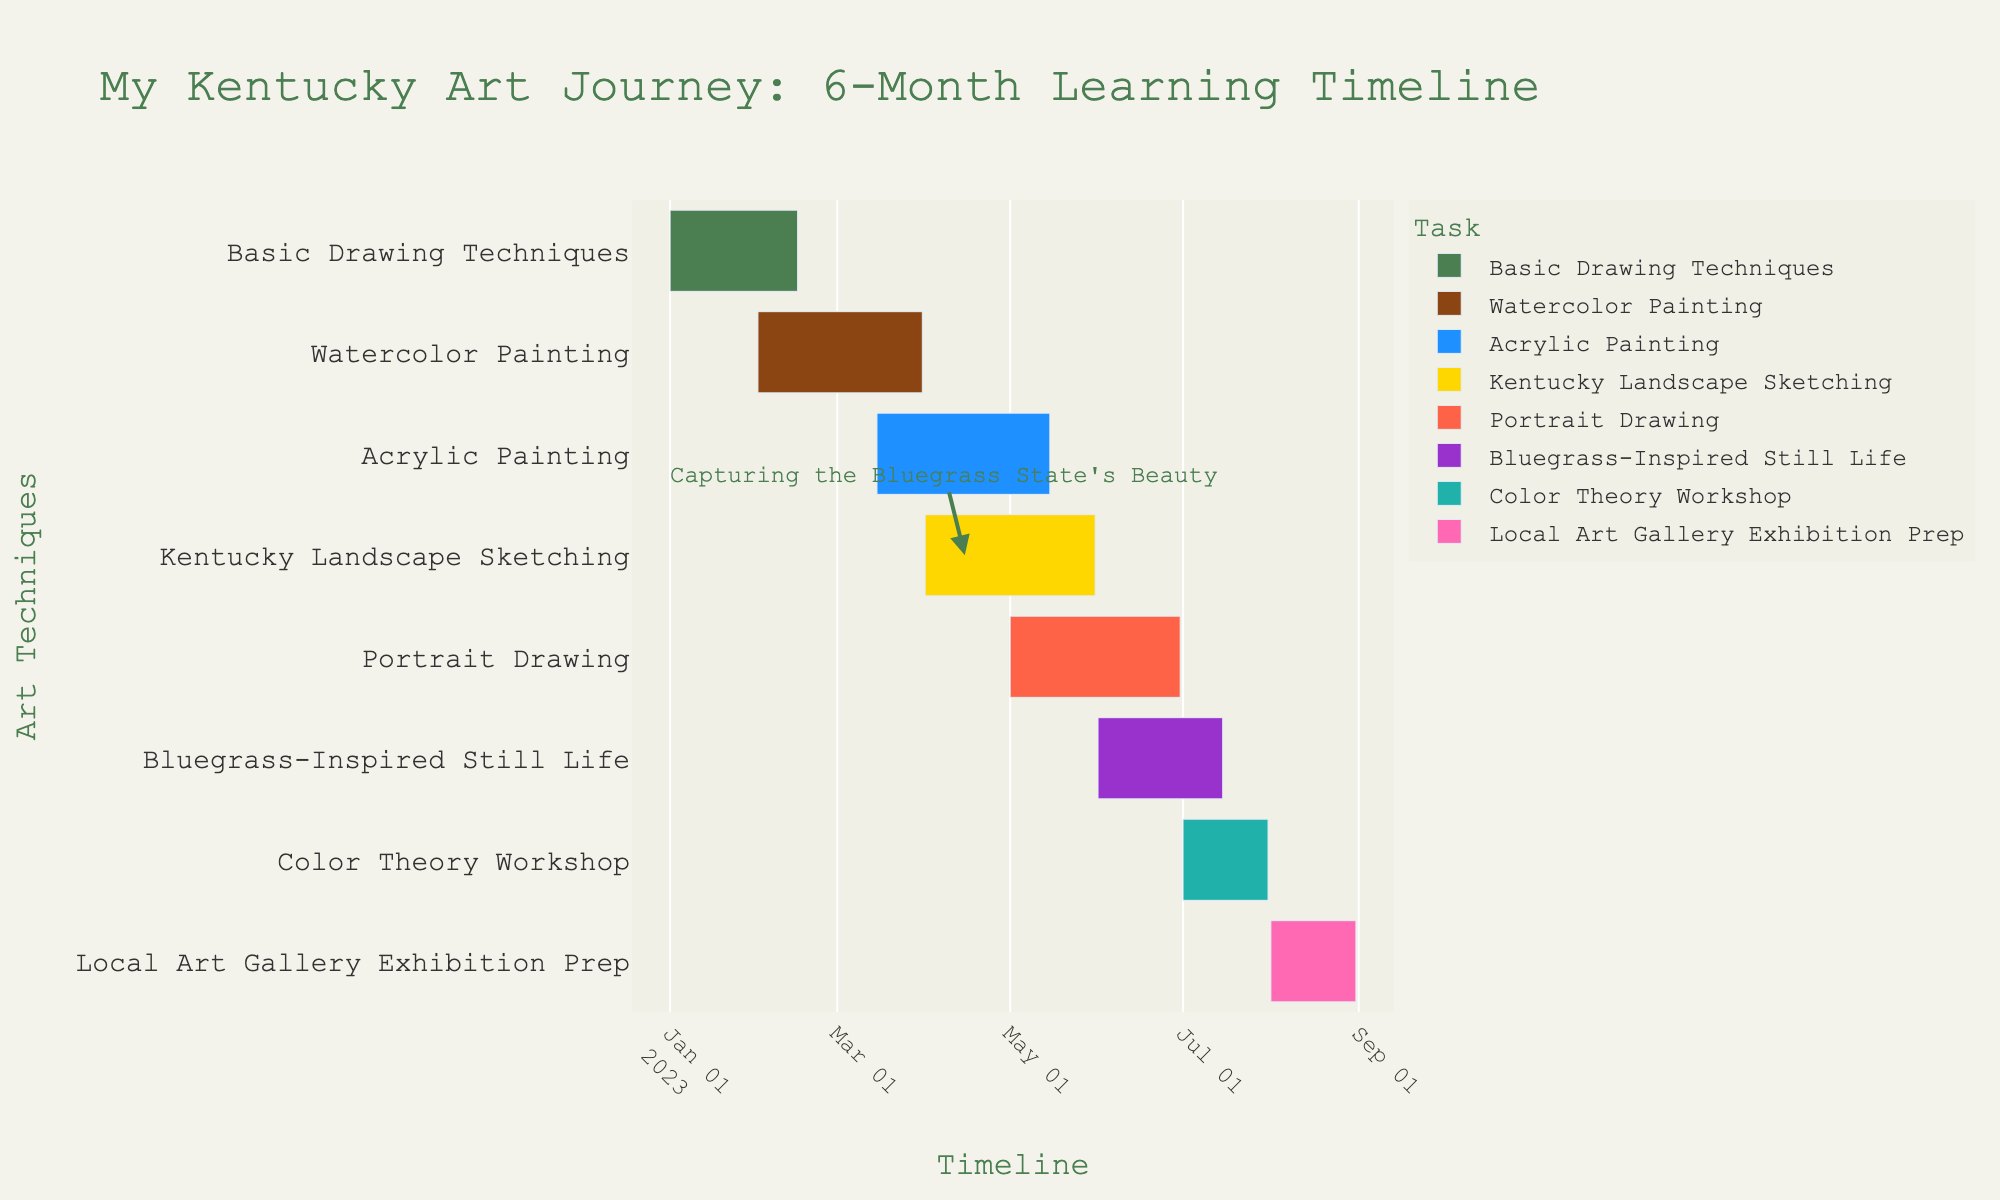What's the title of the Gantt Chart? The title is displayed prominently at the top of the chart to describe what the timeline is about. Here, it reads "My Kentucky Art Journey: 6-Month Learning Timeline".
Answer: My Kentucky Art Journey: 6-Month Learning Timeline How many art techniques are tracked in the Gantt Chart? Each task in the chart corresponds to a different art technique being tracked. You can count the number of unique tasks listed on the y-axis.
Answer: 8 What is the start date of the "Basic Drawing Techniques" task? The start date for each task is shown on the x-axis. For "Basic Drawing Techniques," it begins at the start of January 2023.
Answer: January 1, 2023 Which task(s) extend into the month of May 2023? Identify the tasks whose bars extend into the month of May by looking at the timeline on the x-axis. Here, "Acrylic Painting," "Kentucky Landscape Sketching," and "Portrait Drawing" all extend into May 2023.
Answer: Acrylic Painting, Kentucky Landscape Sketching, Portrait Drawing What's the duration of the "Color Theory Workshop"? To find the duration, subtract the start date from the end date. The "Color Theory Workshop" starts on July 1 and ends on July 31, giving it a duration of 31 days.
Answer: 31 days Which two tasks have overlapping time periods in March 2023? By examining the timeline, find which tasks' bars overlap during March. Both "Watercolor Painting" and "Acrylic Painting" span parts of March.
Answer: Watercolor Painting and Acrylic Painting Which task has an annotation related to the Bluegrass State's beauty? There's a specific annotation on the chart related to capturing Kentucky's beauty. It's associated with "Kentucky Landscape Sketching."
Answer: Kentucky Landscape Sketching How many tasks are active in April 2023? To count how many tasks are active in April, look at the timeline bars that overlap with the month of April. "Watercolor Painting," "Acrylic Painting," and "Kentucky Landscape Sketching" are all active.
Answer: 3 Which task has the latest end date? To determine the task with the latest end date, look for the task that extends the farthest right on the x-axis. Here, it's "Local Art Gallery Exhibition Prep," which ends on August 31, 2023.
Answer: Local Art Gallery Exhibition Prep What is the gap between the end date of "Acrylic Painting" and the start date of "Bluegrass-Inspired Still Life"? "Acrylic Painting" ends on May 15, while "Bluegrass-Inspired Still Life" starts on June 1. The gap is the difference between these dates, which is 16 days.
Answer: 16 days 